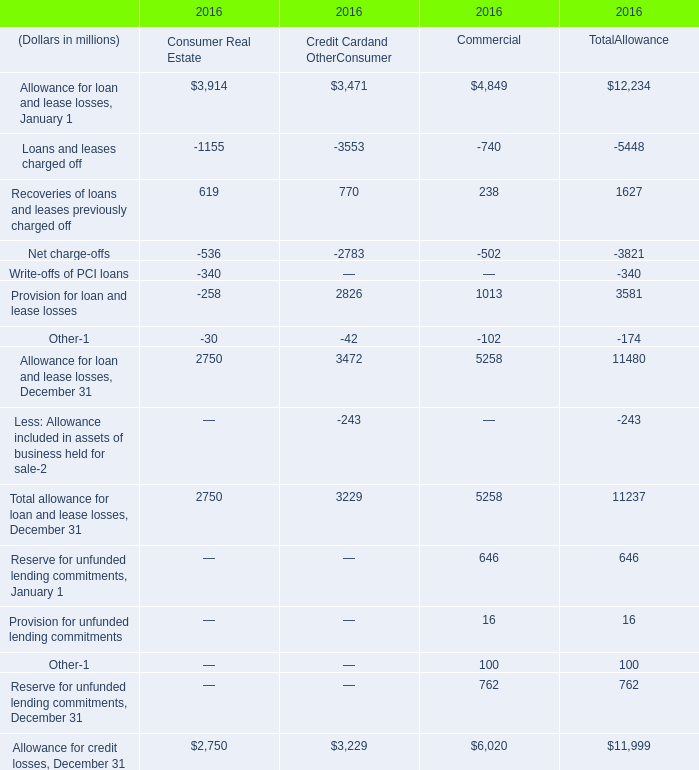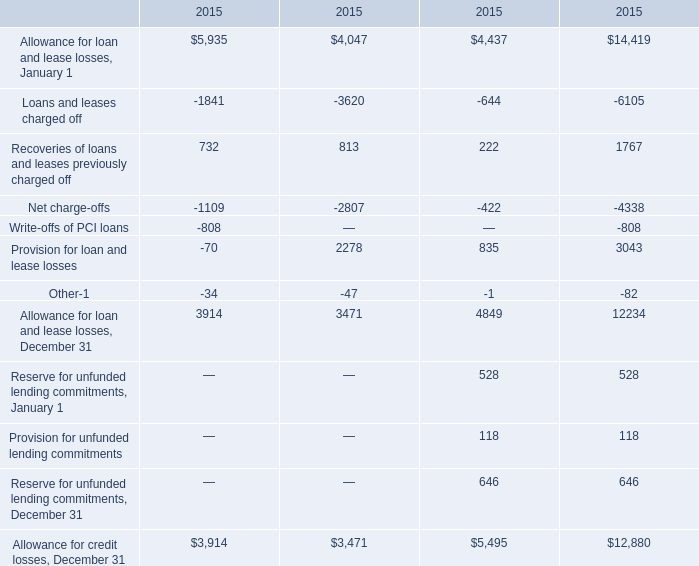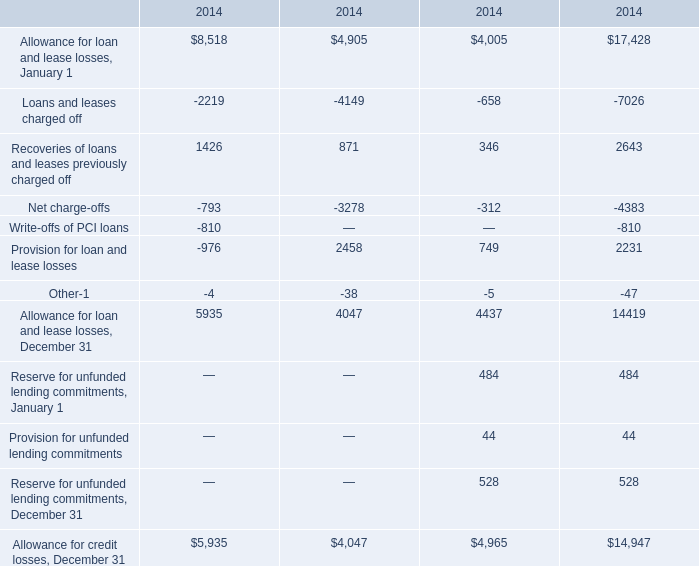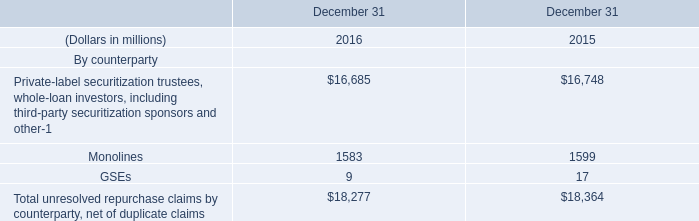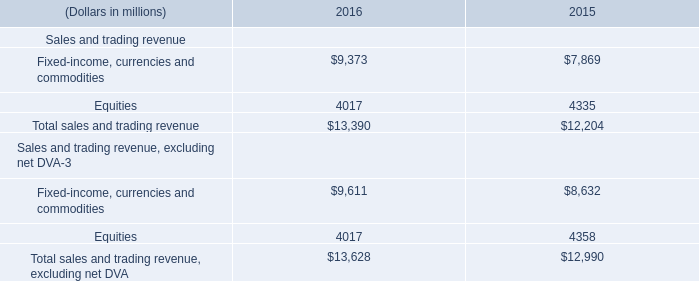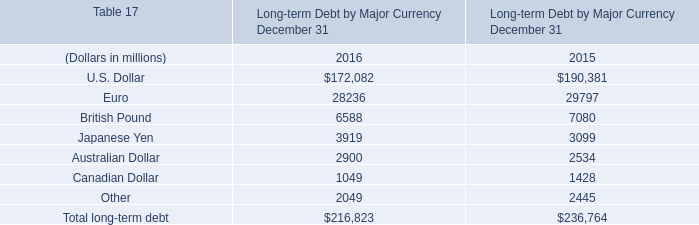What's the total amount of Recoveries of loans and leases previously charged off without those Loans and leases charged off smaller than -1000, in 2015? 
Answer: 222. 